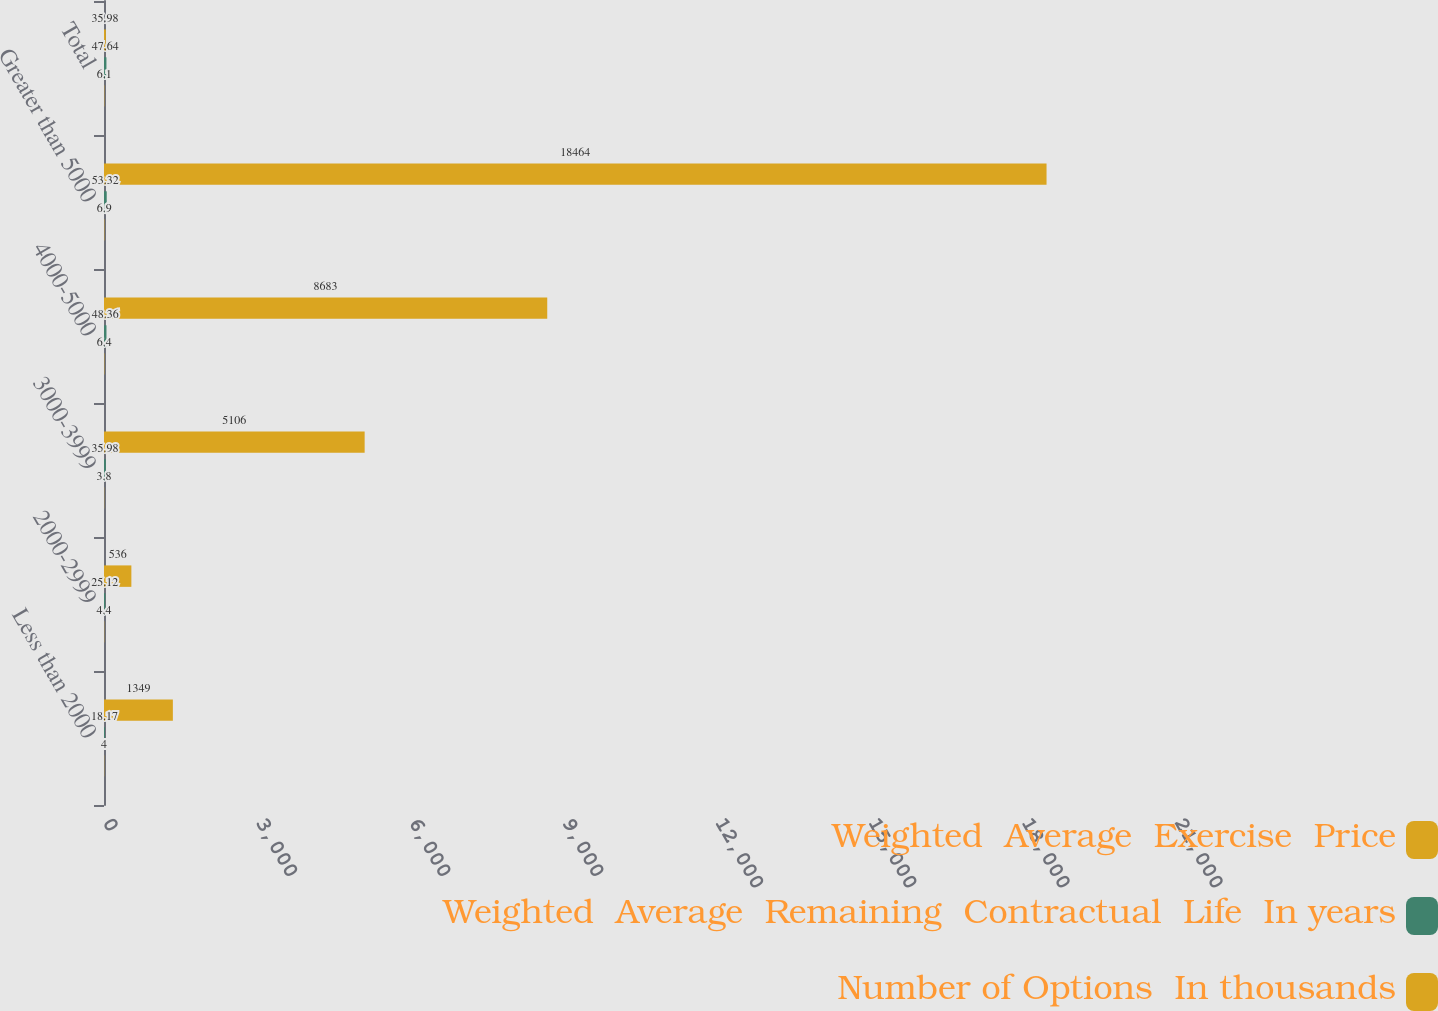Convert chart to OTSL. <chart><loc_0><loc_0><loc_500><loc_500><stacked_bar_chart><ecel><fcel>Less than 2000<fcel>2000-2999<fcel>3000-3999<fcel>4000-5000<fcel>Greater than 5000<fcel>Total<nl><fcel>Weighted  Average  Exercise  Price<fcel>1349<fcel>536<fcel>5106<fcel>8683<fcel>18464<fcel>35.98<nl><fcel>Weighted  Average  Remaining  Contractual  Life  In years<fcel>18.17<fcel>25.12<fcel>35.98<fcel>48.36<fcel>53.32<fcel>47.64<nl><fcel>Number of Options  In thousands<fcel>4<fcel>4.4<fcel>3.8<fcel>6.4<fcel>6.9<fcel>6.1<nl></chart> 